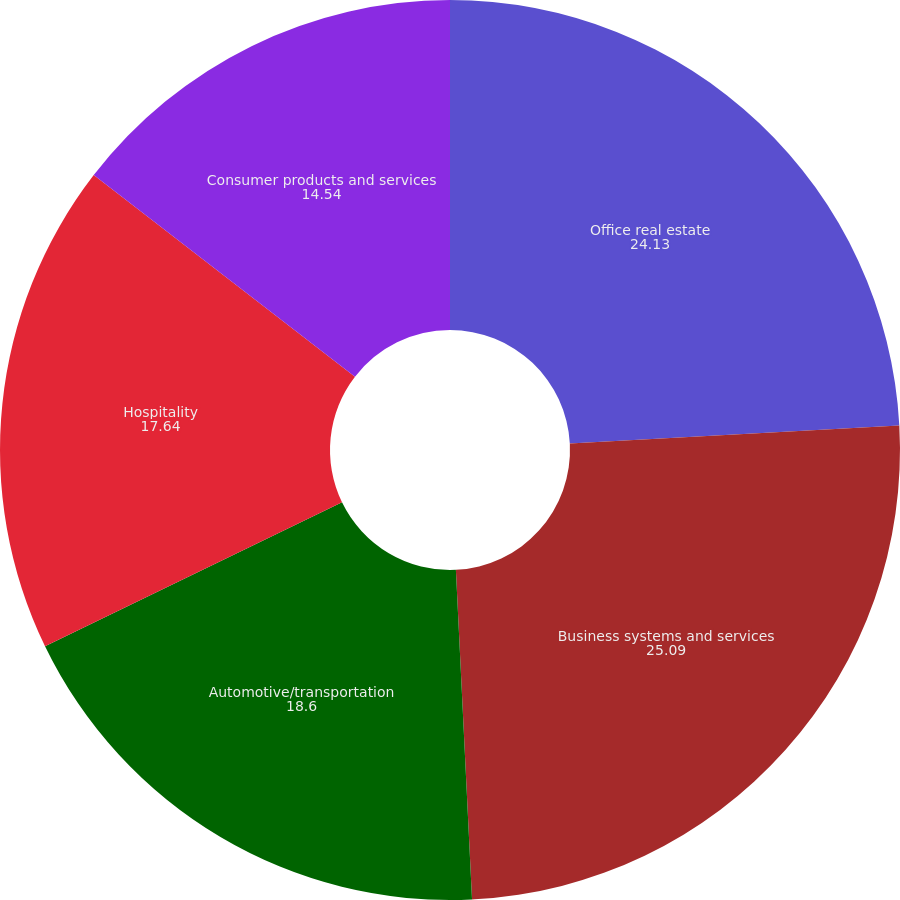Convert chart. <chart><loc_0><loc_0><loc_500><loc_500><pie_chart><fcel>Office real estate<fcel>Business systems and services<fcel>Automotive/transportation<fcel>Hospitality<fcel>Consumer products and services<nl><fcel>24.13%<fcel>25.09%<fcel>18.6%<fcel>17.64%<fcel>14.54%<nl></chart> 